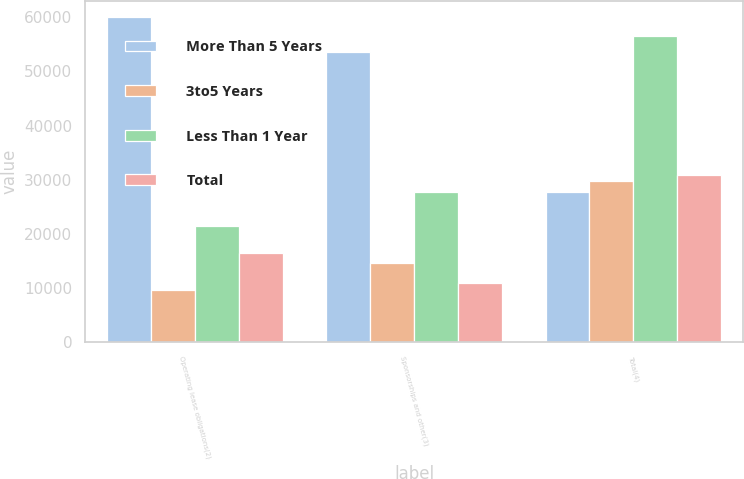Convert chart to OTSL. <chart><loc_0><loc_0><loc_500><loc_500><stacked_bar_chart><ecel><fcel>Operating lease obligations(2)<fcel>Sponsorships and other(3)<fcel>Total(4)<nl><fcel>More Than 5 Years<fcel>60062<fcel>53584<fcel>27770<nl><fcel>3to5 Years<fcel>9697<fcel>14684<fcel>29730<nl><fcel>Less Than 1 Year<fcel>21465<fcel>27770<fcel>56607<nl><fcel>Total<fcel>16515<fcel>10927<fcel>30823<nl></chart> 